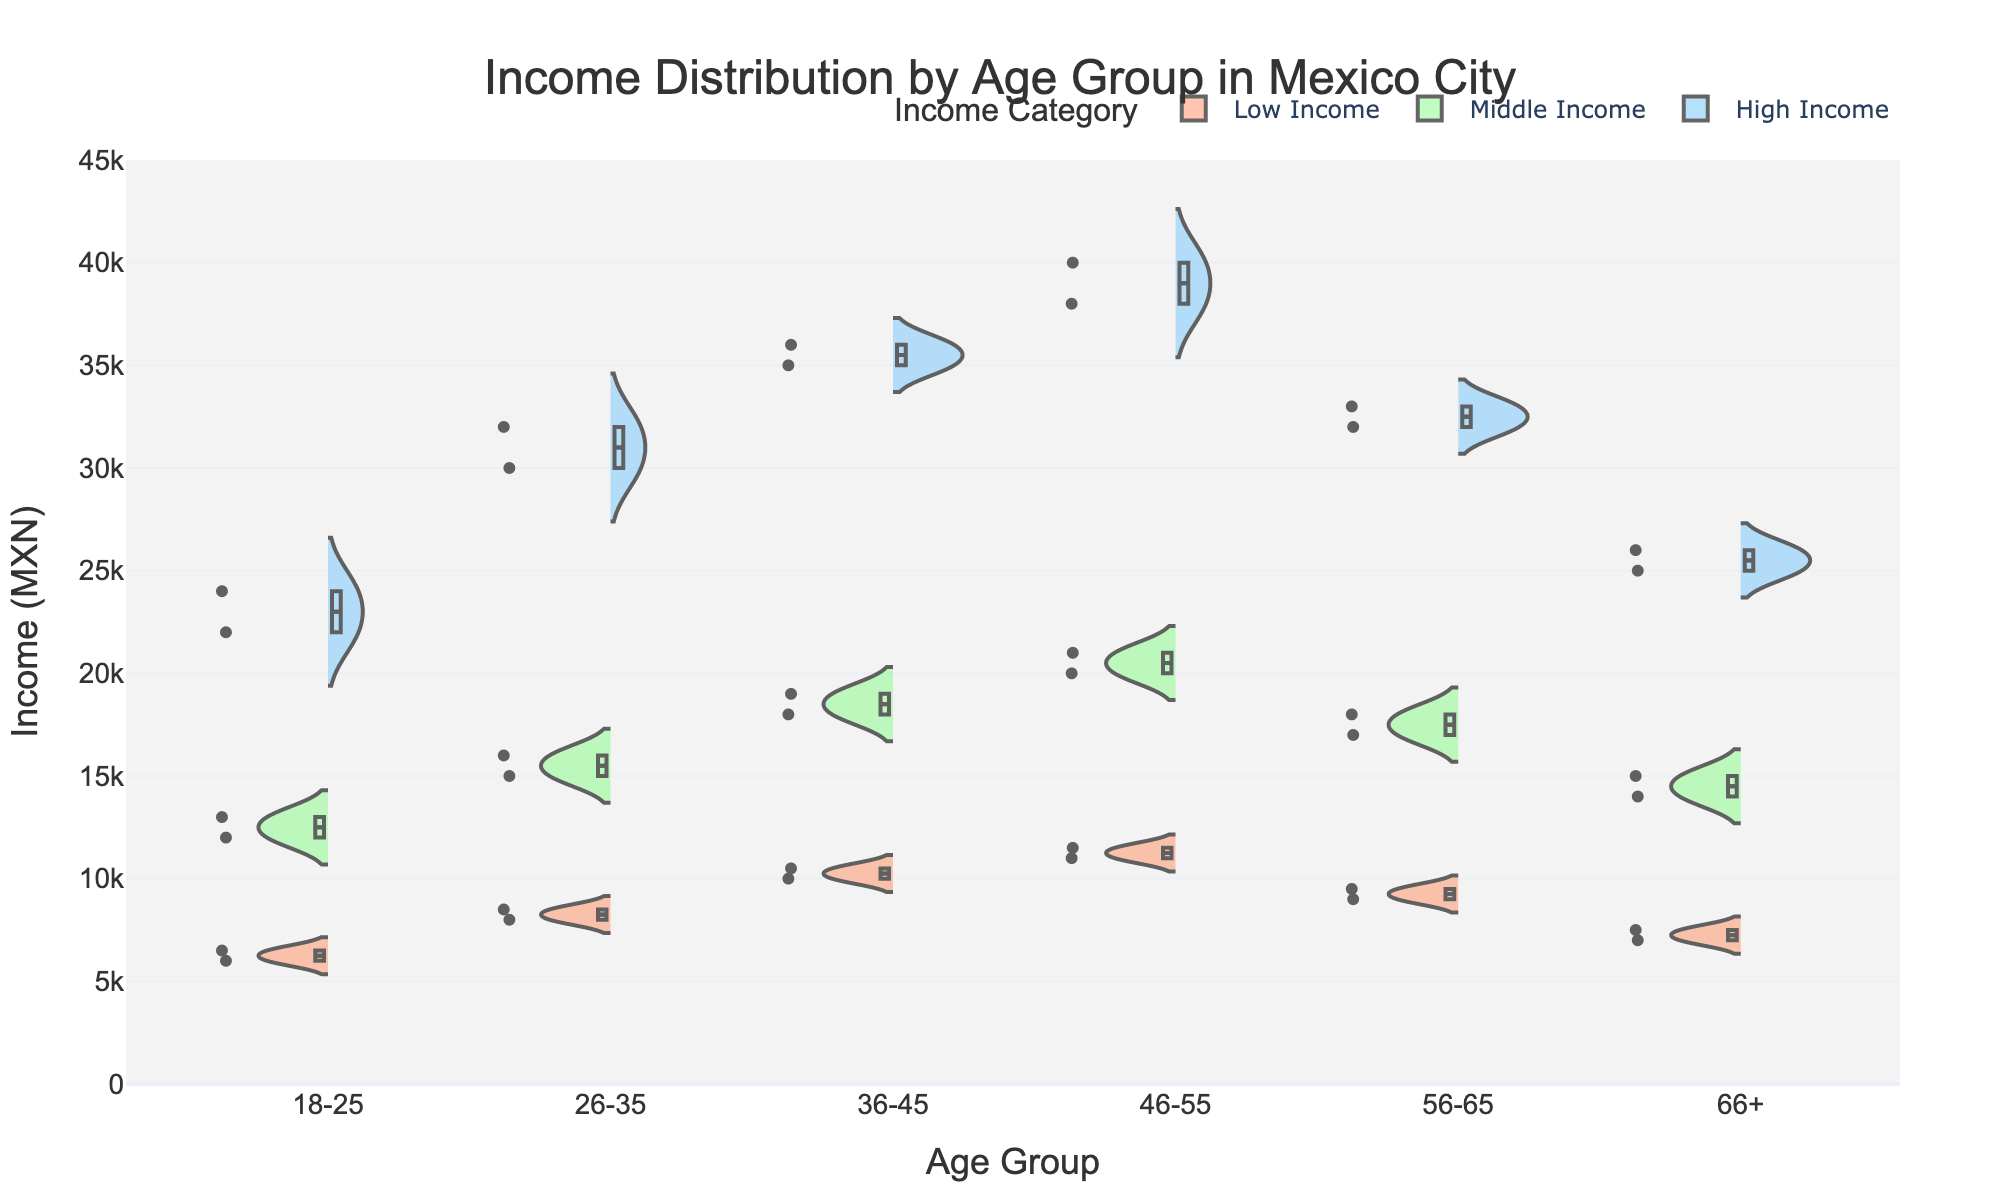What's the title of the figure? The title of the figure is typically displayed at the top center of the plot. In this case, the title is given in the plot's layout configuration. It reads "Income Distribution by Age Group in Mexico City".
Answer: Income Distribution by Age Group in Mexico City What are the age groups displayed on the x-axis? The age groups are enumerated as labels on the x-axis of the plot. These labels correspond to the different age groups specified in the data: "18-25", "26-35", "36-45", "46-55", "56-65", and "66+".
Answer: 18-25, 26-35, 36-45, 46-55, 56-65, 66+ What is the income range shown on the y-axis of the plot? The y-axis typically displays the range of income values present in the dataset. In this plot, the y-axis ranges from 0 to 45,000 MXN, as stated in the `update_yaxes` function.
Answer: 0 to 45,000 MXN Which income category has the widest distribution for the age group 46-55? To determine the category with the widest distribution, we look at the spread of the violin plot within the 46-55 age group. The distribution for 'High Income' extends from approximately 38,000 to 40,000 MXN, which is wider compared to other income categories for that age group.
Answer: High Income What is the mean income for "High Income" individuals in the 36-45 age group? The mean income is represented by a solid line within each violin plot. For the "High Income" individuals in the 36-45 age group, this would be the central line within that specific segment. It should be around 35,500 MXN.
Answer: 35,500 MXN For which age group is the "Middle Income" distribution skewed towards the lower end? A distribution is skewed towards the lower end if it has a long tail on the lower income side. Observing the violin plots, the "Middle Income" distribution for the 56-65 age group appears skewed towards the lower end as the density is higher towards the bottom of the distribution.
Answer: 56-65 Compare the median income of the "Middle Income" category for the 18-25 and 26-35 age groups. Which is higher? The median income for each category is indicated by the middle line in the box plot within each violin. For the "Middle Income" category, the median for the 18-25 age group is around 12,500 MXN, whereas for the 26-35 age group, it is around 15,500 MXN. Thus, the median income is higher for the 26-35 age group.
Answer: 26-35 Which income category has the most overlap between the different age groups? Overlap can be assessed by looking at how the distributions of different age groups intersect within each income category. The "High Income" category shows significant overlap, particularly in the range from 20,000 to 36,000 MXN, across different age groups.
Answer: High Income Identify the age group with the lowest median income in the "Low Income" category. The median income in a violin plot can be identified by the center line within each "Low Income" section. For all age groups, the median for the "Low Income" category is lowest for the 18-25 age group.
Answer: 18-25 